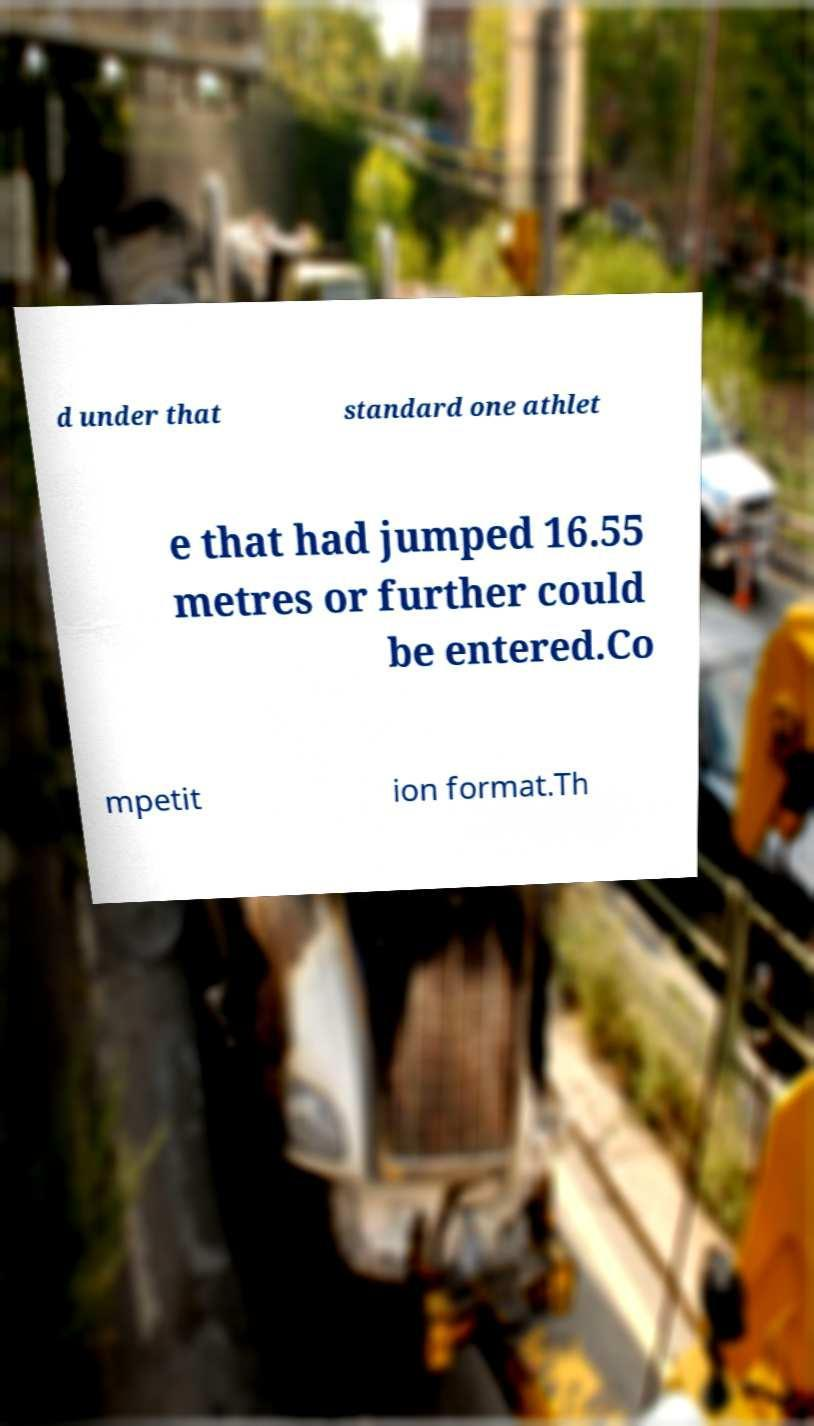Please read and relay the text visible in this image. What does it say? d under that standard one athlet e that had jumped 16.55 metres or further could be entered.Co mpetit ion format.Th 